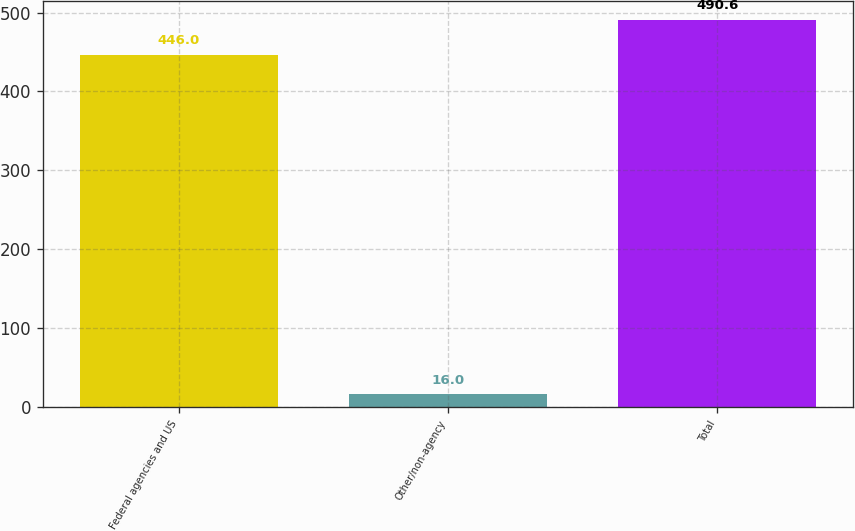Convert chart. <chart><loc_0><loc_0><loc_500><loc_500><bar_chart><fcel>Federal agencies and US<fcel>Other/non-agency<fcel>Total<nl><fcel>446<fcel>16<fcel>490.6<nl></chart> 